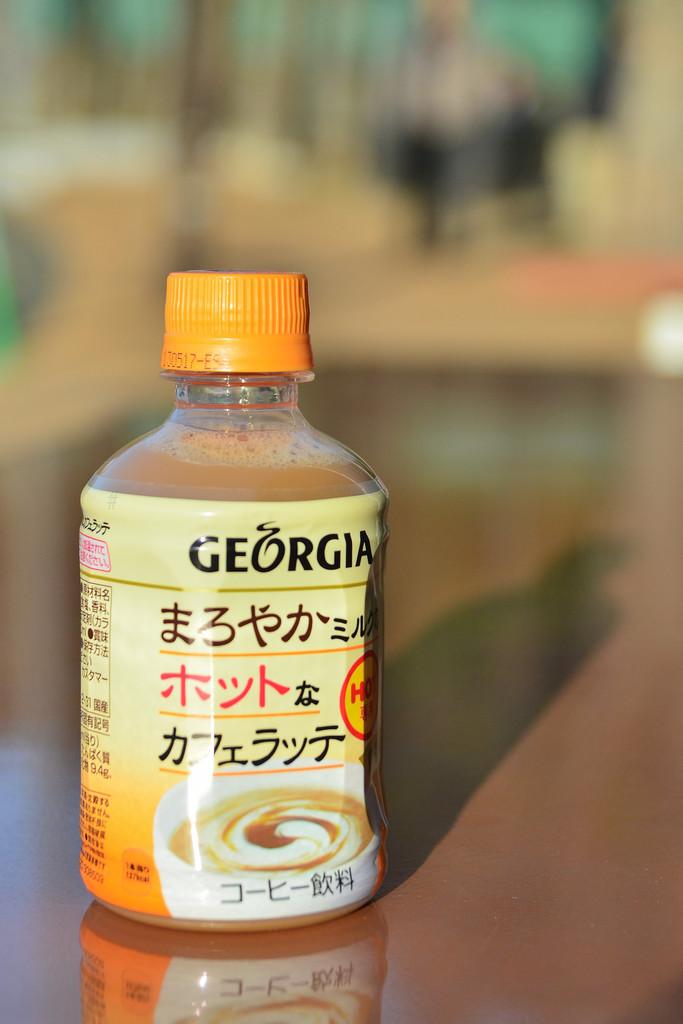What state is mentioned on the jar?
Keep it short and to the point. Georgia. 